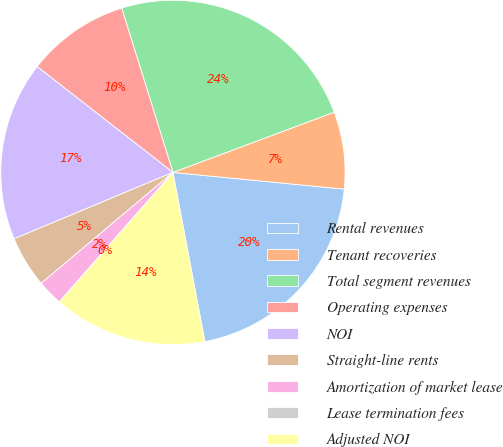<chart> <loc_0><loc_0><loc_500><loc_500><pie_chart><fcel>Rental revenues<fcel>Tenant recoveries<fcel>Total segment revenues<fcel>Operating expenses<fcel>NOI<fcel>Straight-line rents<fcel>Amortization of market lease<fcel>Lease termination fees<fcel>Adjusted NOI<nl><fcel>20.48%<fcel>7.24%<fcel>24.12%<fcel>9.65%<fcel>16.84%<fcel>4.83%<fcel>2.41%<fcel>0.0%<fcel>14.43%<nl></chart> 